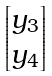Convert formula to latex. <formula><loc_0><loc_0><loc_500><loc_500>\begin{bmatrix} y _ { 3 } \\ y _ { 4 } \end{bmatrix}</formula> 